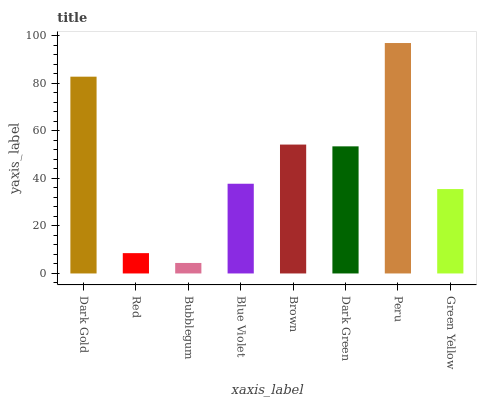Is Bubblegum the minimum?
Answer yes or no. Yes. Is Peru the maximum?
Answer yes or no. Yes. Is Red the minimum?
Answer yes or no. No. Is Red the maximum?
Answer yes or no. No. Is Dark Gold greater than Red?
Answer yes or no. Yes. Is Red less than Dark Gold?
Answer yes or no. Yes. Is Red greater than Dark Gold?
Answer yes or no. No. Is Dark Gold less than Red?
Answer yes or no. No. Is Dark Green the high median?
Answer yes or no. Yes. Is Blue Violet the low median?
Answer yes or no. Yes. Is Brown the high median?
Answer yes or no. No. Is Dark Gold the low median?
Answer yes or no. No. 